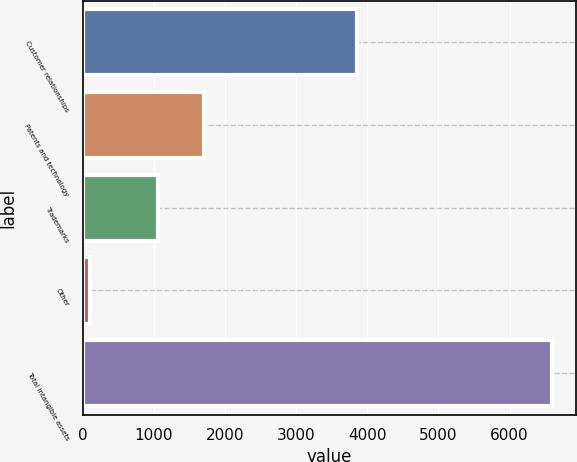Convert chart. <chart><loc_0><loc_0><loc_500><loc_500><bar_chart><fcel>Customer relationships<fcel>Patents and technology<fcel>Trademarks<fcel>Other<fcel>Total intangible assets<nl><fcel>3859<fcel>1701.9<fcel>1052<fcel>103<fcel>6602<nl></chart> 